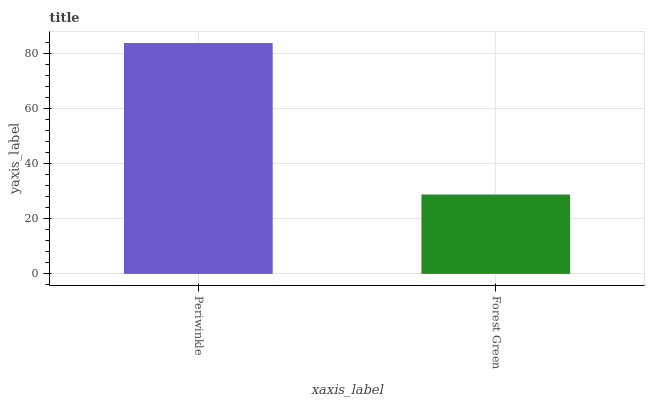Is Forest Green the minimum?
Answer yes or no. Yes. Is Periwinkle the maximum?
Answer yes or no. Yes. Is Forest Green the maximum?
Answer yes or no. No. Is Periwinkle greater than Forest Green?
Answer yes or no. Yes. Is Forest Green less than Periwinkle?
Answer yes or no. Yes. Is Forest Green greater than Periwinkle?
Answer yes or no. No. Is Periwinkle less than Forest Green?
Answer yes or no. No. Is Periwinkle the high median?
Answer yes or no. Yes. Is Forest Green the low median?
Answer yes or no. Yes. Is Forest Green the high median?
Answer yes or no. No. Is Periwinkle the low median?
Answer yes or no. No. 